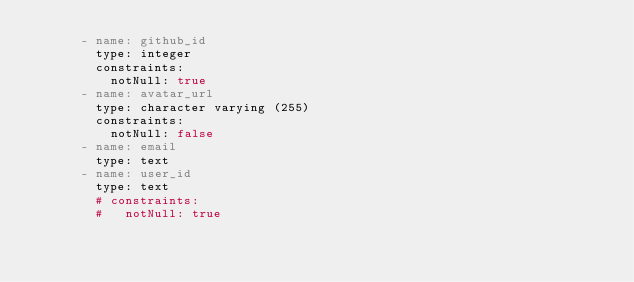<code> <loc_0><loc_0><loc_500><loc_500><_YAML_>      - name: github_id
        type: integer
        constraints:
          notNull: true
      - name: avatar_url
        type: character varying (255)
        constraints:
          notNull: false
      - name: email
        type: text
      - name: user_id
        type: text
        # constraints:
        #   notNull: true
</code> 